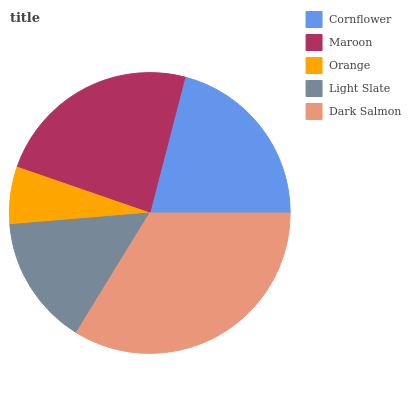Is Orange the minimum?
Answer yes or no. Yes. Is Dark Salmon the maximum?
Answer yes or no. Yes. Is Maroon the minimum?
Answer yes or no. No. Is Maroon the maximum?
Answer yes or no. No. Is Maroon greater than Cornflower?
Answer yes or no. Yes. Is Cornflower less than Maroon?
Answer yes or no. Yes. Is Cornflower greater than Maroon?
Answer yes or no. No. Is Maroon less than Cornflower?
Answer yes or no. No. Is Cornflower the high median?
Answer yes or no. Yes. Is Cornflower the low median?
Answer yes or no. Yes. Is Light Slate the high median?
Answer yes or no. No. Is Dark Salmon the low median?
Answer yes or no. No. 